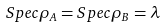<formula> <loc_0><loc_0><loc_500><loc_500>S p e c \rho _ { A } = S p e c \rho _ { B } = \lambda</formula> 